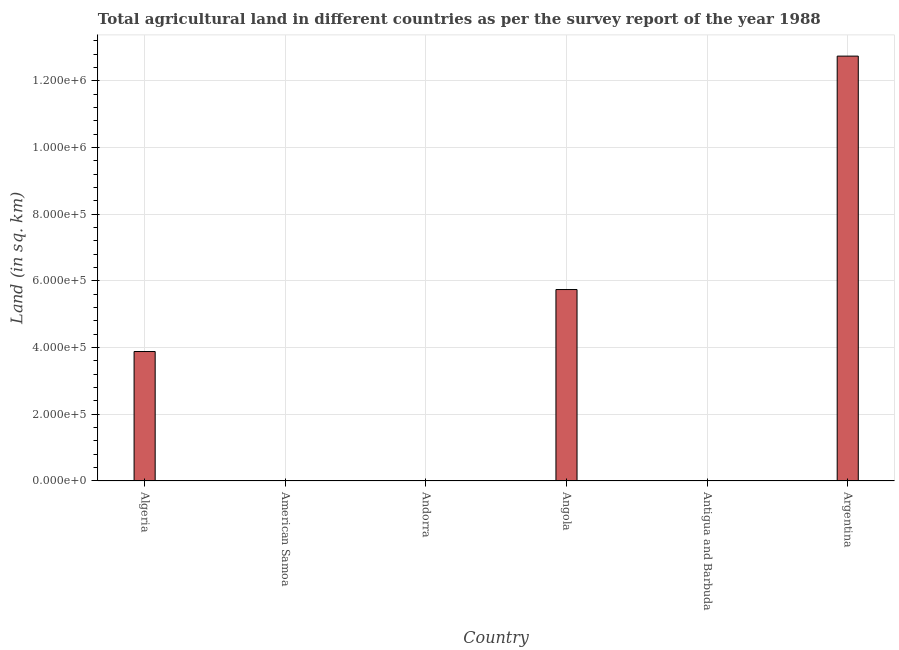Does the graph contain any zero values?
Offer a terse response. No. What is the title of the graph?
Offer a very short reply. Total agricultural land in different countries as per the survey report of the year 1988. What is the label or title of the X-axis?
Offer a terse response. Country. What is the label or title of the Y-axis?
Your answer should be compact. Land (in sq. km). What is the agricultural land in Angola?
Ensure brevity in your answer.  5.74e+05. Across all countries, what is the maximum agricultural land?
Ensure brevity in your answer.  1.27e+06. In which country was the agricultural land maximum?
Ensure brevity in your answer.  Argentina. In which country was the agricultural land minimum?
Make the answer very short. American Samoa. What is the sum of the agricultural land?
Offer a terse response. 2.24e+06. What is the difference between the agricultural land in Andorra and Angola?
Provide a succinct answer. -5.74e+05. What is the average agricultural land per country?
Give a very brief answer. 3.73e+05. What is the median agricultural land?
Offer a very short reply. 1.94e+05. In how many countries, is the agricultural land greater than 200000 sq. km?
Your response must be concise. 3. What is the ratio of the agricultural land in American Samoa to that in Andorra?
Give a very brief answer. 0.16. Is the agricultural land in American Samoa less than that in Angola?
Provide a succinct answer. Yes. Is the difference between the agricultural land in Andorra and Argentina greater than the difference between any two countries?
Ensure brevity in your answer.  No. What is the difference between the highest and the second highest agricultural land?
Offer a terse response. 7.00e+05. Is the sum of the agricultural land in Angola and Argentina greater than the maximum agricultural land across all countries?
Provide a short and direct response. Yes. What is the difference between the highest and the lowest agricultural land?
Ensure brevity in your answer.  1.27e+06. What is the difference between two consecutive major ticks on the Y-axis?
Ensure brevity in your answer.  2.00e+05. What is the Land (in sq. km) of Algeria?
Offer a very short reply. 3.88e+05. What is the Land (in sq. km) in American Samoa?
Your response must be concise. 30. What is the Land (in sq. km) of Andorra?
Offer a terse response. 190. What is the Land (in sq. km) of Angola?
Provide a succinct answer. 5.74e+05. What is the Land (in sq. km) in Antigua and Barbuda?
Ensure brevity in your answer.  90. What is the Land (in sq. km) in Argentina?
Make the answer very short. 1.27e+06. What is the difference between the Land (in sq. km) in Algeria and American Samoa?
Your answer should be very brief. 3.88e+05. What is the difference between the Land (in sq. km) in Algeria and Andorra?
Offer a very short reply. 3.88e+05. What is the difference between the Land (in sq. km) in Algeria and Angola?
Offer a very short reply. -1.86e+05. What is the difference between the Land (in sq. km) in Algeria and Antigua and Barbuda?
Make the answer very short. 3.88e+05. What is the difference between the Land (in sq. km) in Algeria and Argentina?
Ensure brevity in your answer.  -8.86e+05. What is the difference between the Land (in sq. km) in American Samoa and Andorra?
Your answer should be compact. -160. What is the difference between the Land (in sq. km) in American Samoa and Angola?
Your response must be concise. -5.74e+05. What is the difference between the Land (in sq. km) in American Samoa and Antigua and Barbuda?
Give a very brief answer. -60. What is the difference between the Land (in sq. km) in American Samoa and Argentina?
Give a very brief answer. -1.27e+06. What is the difference between the Land (in sq. km) in Andorra and Angola?
Offer a very short reply. -5.74e+05. What is the difference between the Land (in sq. km) in Andorra and Argentina?
Offer a terse response. -1.27e+06. What is the difference between the Land (in sq. km) in Angola and Antigua and Barbuda?
Ensure brevity in your answer.  5.74e+05. What is the difference between the Land (in sq. km) in Angola and Argentina?
Keep it short and to the point. -7.00e+05. What is the difference between the Land (in sq. km) in Antigua and Barbuda and Argentina?
Make the answer very short. -1.27e+06. What is the ratio of the Land (in sq. km) in Algeria to that in American Samoa?
Your answer should be very brief. 1.29e+04. What is the ratio of the Land (in sq. km) in Algeria to that in Andorra?
Give a very brief answer. 2043. What is the ratio of the Land (in sq. km) in Algeria to that in Angola?
Provide a short and direct response. 0.68. What is the ratio of the Land (in sq. km) in Algeria to that in Antigua and Barbuda?
Provide a short and direct response. 4313. What is the ratio of the Land (in sq. km) in Algeria to that in Argentina?
Keep it short and to the point. 0.3. What is the ratio of the Land (in sq. km) in American Samoa to that in Andorra?
Your answer should be compact. 0.16. What is the ratio of the Land (in sq. km) in American Samoa to that in Angola?
Give a very brief answer. 0. What is the ratio of the Land (in sq. km) in American Samoa to that in Antigua and Barbuda?
Make the answer very short. 0.33. What is the ratio of the Land (in sq. km) in Andorra to that in Angola?
Keep it short and to the point. 0. What is the ratio of the Land (in sq. km) in Andorra to that in Antigua and Barbuda?
Your answer should be compact. 2.11. What is the ratio of the Land (in sq. km) in Angola to that in Antigua and Barbuda?
Provide a succinct answer. 6377.78. What is the ratio of the Land (in sq. km) in Angola to that in Argentina?
Give a very brief answer. 0.45. 